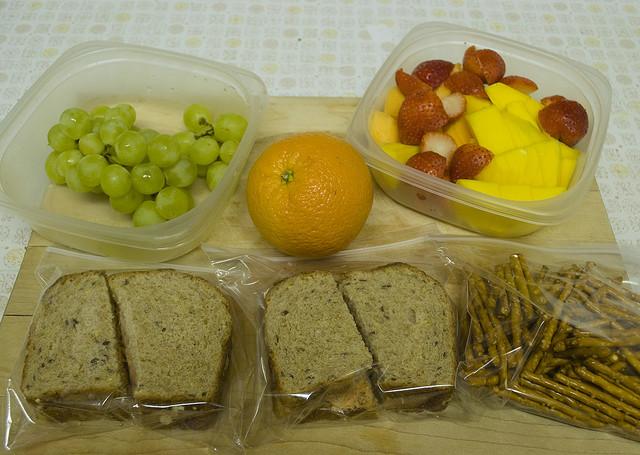Is this a well balanced meal?
Be succinct. Yes. Are any of the items served in a baggie?
Write a very short answer. Yes. What is the green fruit?
Keep it brief. Grapes. How many containers are in the photo?
Write a very short answer. 2. How many grapes are on the plate?
Write a very short answer. 23. What is the green and red fruit?
Keep it brief. Grapes and strawberries. How many types of fruits are shown in the picture?
Short answer required. 4. Was this food served in a fine dining establishment?
Write a very short answer. No. What kind of bread is on the plate?
Short answer required. Wheat. What is the orange object in the middle?
Concise answer only. Orange. Is this a balanced meal?
Short answer required. Yes. How many yellow donuts are on the table?
Concise answer only. 0. What is the bowl made of?
Short answer required. Plastic. What are the red objects?
Give a very brief answer. Strawberries. What is the container on?
Short answer required. Cutting board. What two items are mixed together in their package?
Answer briefly. Strawberries and mango. What shape are the containers?
Short answer required. Square. How many different kinds of yellow fruit are in the bowl?
Write a very short answer. 1. 